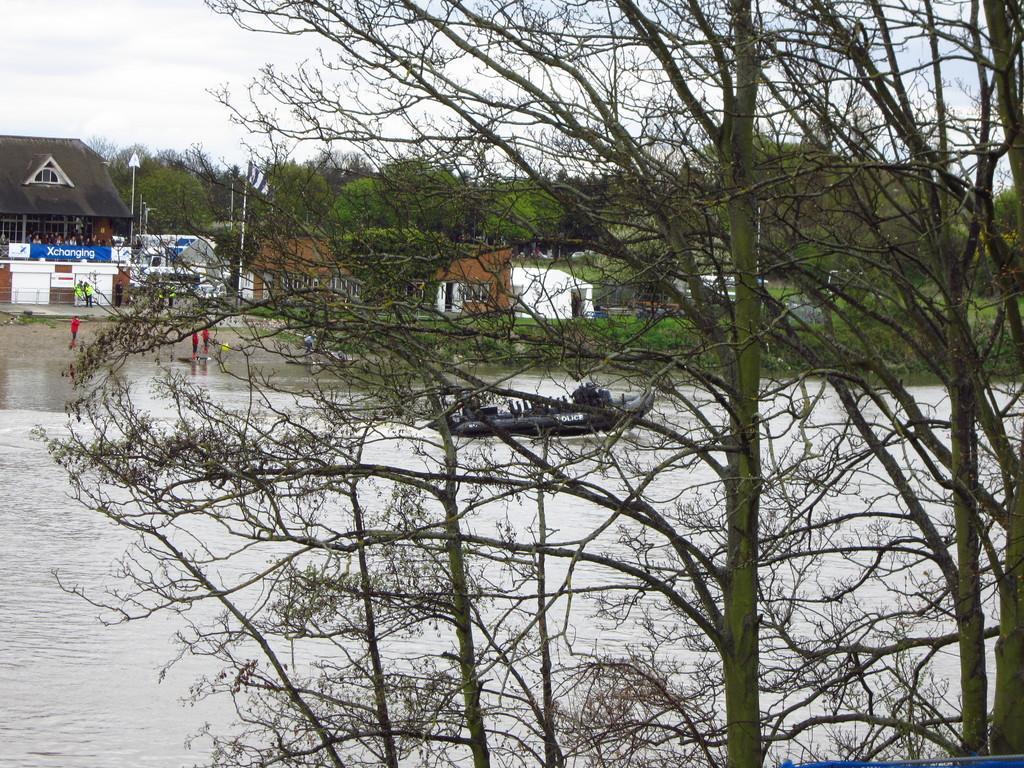Please provide a concise description of this image. In this image there is a boat in the water, there are few people in the boat, there are few people beside the water, few houses, a flag hanging to one of the poles, few trees and the sky. 